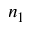Convert formula to latex. <formula><loc_0><loc_0><loc_500><loc_500>n _ { 1 }</formula> 